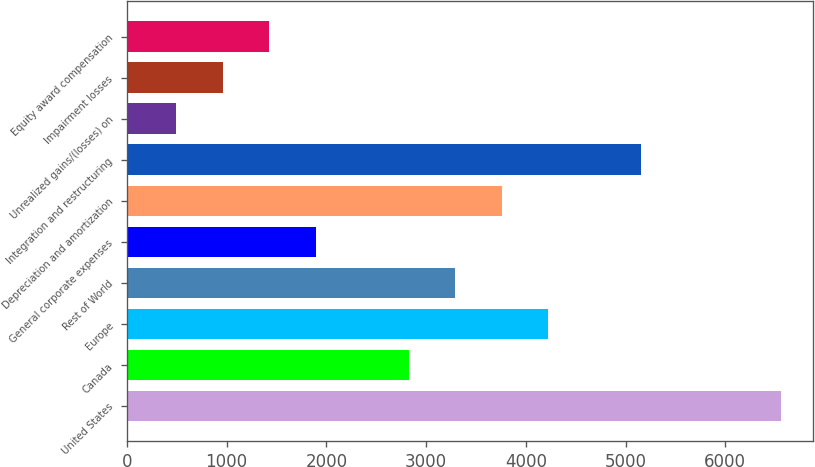Convert chart to OTSL. <chart><loc_0><loc_0><loc_500><loc_500><bar_chart><fcel>United States<fcel>Canada<fcel>Europe<fcel>Rest of World<fcel>General corporate expenses<fcel>Depreciation and amortization<fcel>Integration and restructuring<fcel>Unrealized gains/(losses) on<fcel>Impairment losses<fcel>Equity award compensation<nl><fcel>6555.2<fcel>2824.8<fcel>4223.7<fcel>3291.1<fcel>1892.2<fcel>3757.4<fcel>5156.3<fcel>493.3<fcel>959.6<fcel>1425.9<nl></chart> 